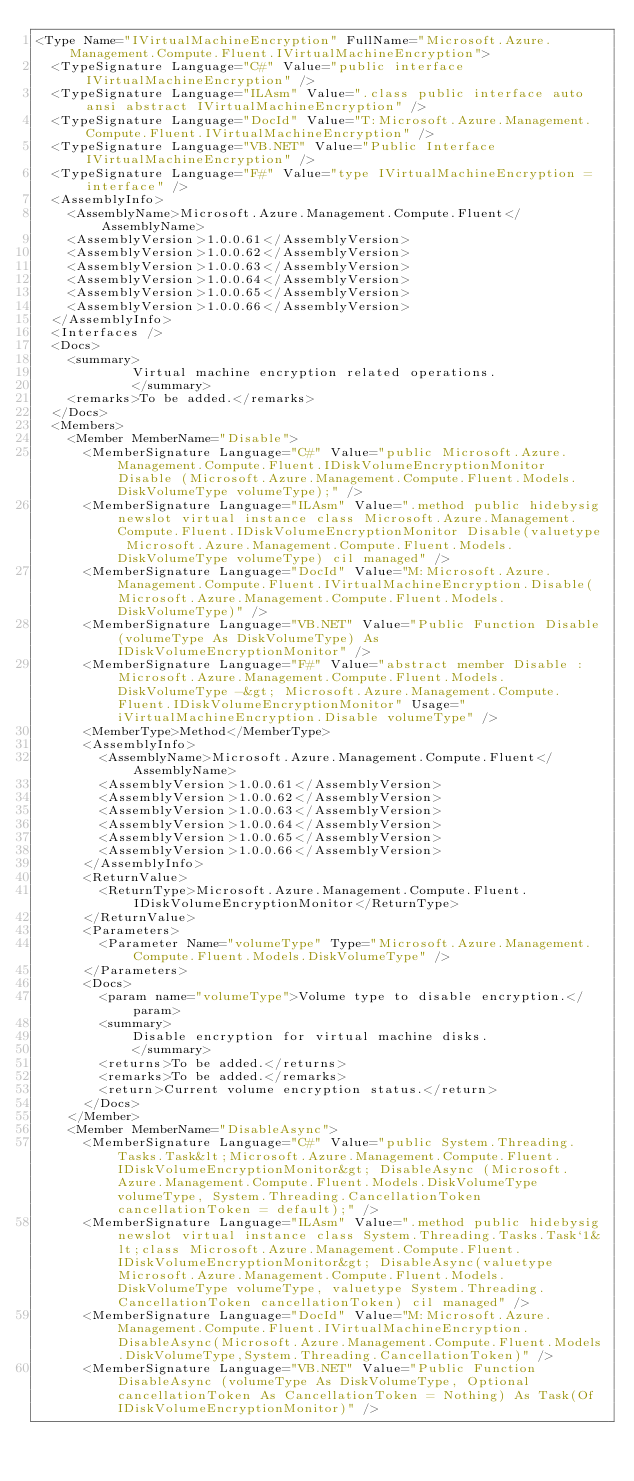<code> <loc_0><loc_0><loc_500><loc_500><_XML_><Type Name="IVirtualMachineEncryption" FullName="Microsoft.Azure.Management.Compute.Fluent.IVirtualMachineEncryption">
  <TypeSignature Language="C#" Value="public interface IVirtualMachineEncryption" />
  <TypeSignature Language="ILAsm" Value=".class public interface auto ansi abstract IVirtualMachineEncryption" />
  <TypeSignature Language="DocId" Value="T:Microsoft.Azure.Management.Compute.Fluent.IVirtualMachineEncryption" />
  <TypeSignature Language="VB.NET" Value="Public Interface IVirtualMachineEncryption" />
  <TypeSignature Language="F#" Value="type IVirtualMachineEncryption = interface" />
  <AssemblyInfo>
    <AssemblyName>Microsoft.Azure.Management.Compute.Fluent</AssemblyName>
    <AssemblyVersion>1.0.0.61</AssemblyVersion>
    <AssemblyVersion>1.0.0.62</AssemblyVersion>
    <AssemblyVersion>1.0.0.63</AssemblyVersion>
    <AssemblyVersion>1.0.0.64</AssemblyVersion>
    <AssemblyVersion>1.0.0.65</AssemblyVersion>
    <AssemblyVersion>1.0.0.66</AssemblyVersion>
  </AssemblyInfo>
  <Interfaces />
  <Docs>
    <summary>
            Virtual machine encryption related operations.
            </summary>
    <remarks>To be added.</remarks>
  </Docs>
  <Members>
    <Member MemberName="Disable">
      <MemberSignature Language="C#" Value="public Microsoft.Azure.Management.Compute.Fluent.IDiskVolumeEncryptionMonitor Disable (Microsoft.Azure.Management.Compute.Fluent.Models.DiskVolumeType volumeType);" />
      <MemberSignature Language="ILAsm" Value=".method public hidebysig newslot virtual instance class Microsoft.Azure.Management.Compute.Fluent.IDiskVolumeEncryptionMonitor Disable(valuetype Microsoft.Azure.Management.Compute.Fluent.Models.DiskVolumeType volumeType) cil managed" />
      <MemberSignature Language="DocId" Value="M:Microsoft.Azure.Management.Compute.Fluent.IVirtualMachineEncryption.Disable(Microsoft.Azure.Management.Compute.Fluent.Models.DiskVolumeType)" />
      <MemberSignature Language="VB.NET" Value="Public Function Disable (volumeType As DiskVolumeType) As IDiskVolumeEncryptionMonitor" />
      <MemberSignature Language="F#" Value="abstract member Disable : Microsoft.Azure.Management.Compute.Fluent.Models.DiskVolumeType -&gt; Microsoft.Azure.Management.Compute.Fluent.IDiskVolumeEncryptionMonitor" Usage="iVirtualMachineEncryption.Disable volumeType" />
      <MemberType>Method</MemberType>
      <AssemblyInfo>
        <AssemblyName>Microsoft.Azure.Management.Compute.Fluent</AssemblyName>
        <AssemblyVersion>1.0.0.61</AssemblyVersion>
        <AssemblyVersion>1.0.0.62</AssemblyVersion>
        <AssemblyVersion>1.0.0.63</AssemblyVersion>
        <AssemblyVersion>1.0.0.64</AssemblyVersion>
        <AssemblyVersion>1.0.0.65</AssemblyVersion>
        <AssemblyVersion>1.0.0.66</AssemblyVersion>
      </AssemblyInfo>
      <ReturnValue>
        <ReturnType>Microsoft.Azure.Management.Compute.Fluent.IDiskVolumeEncryptionMonitor</ReturnType>
      </ReturnValue>
      <Parameters>
        <Parameter Name="volumeType" Type="Microsoft.Azure.Management.Compute.Fluent.Models.DiskVolumeType" />
      </Parameters>
      <Docs>
        <param name="volumeType">Volume type to disable encryption.</param>
        <summary>
            Disable encryption for virtual machine disks.
            </summary>
        <returns>To be added.</returns>
        <remarks>To be added.</remarks>
        <return>Current volume encryption status.</return>
      </Docs>
    </Member>
    <Member MemberName="DisableAsync">
      <MemberSignature Language="C#" Value="public System.Threading.Tasks.Task&lt;Microsoft.Azure.Management.Compute.Fluent.IDiskVolumeEncryptionMonitor&gt; DisableAsync (Microsoft.Azure.Management.Compute.Fluent.Models.DiskVolumeType volumeType, System.Threading.CancellationToken cancellationToken = default);" />
      <MemberSignature Language="ILAsm" Value=".method public hidebysig newslot virtual instance class System.Threading.Tasks.Task`1&lt;class Microsoft.Azure.Management.Compute.Fluent.IDiskVolumeEncryptionMonitor&gt; DisableAsync(valuetype Microsoft.Azure.Management.Compute.Fluent.Models.DiskVolumeType volumeType, valuetype System.Threading.CancellationToken cancellationToken) cil managed" />
      <MemberSignature Language="DocId" Value="M:Microsoft.Azure.Management.Compute.Fluent.IVirtualMachineEncryption.DisableAsync(Microsoft.Azure.Management.Compute.Fluent.Models.DiskVolumeType,System.Threading.CancellationToken)" />
      <MemberSignature Language="VB.NET" Value="Public Function DisableAsync (volumeType As DiskVolumeType, Optional cancellationToken As CancellationToken = Nothing) As Task(Of IDiskVolumeEncryptionMonitor)" /></code> 